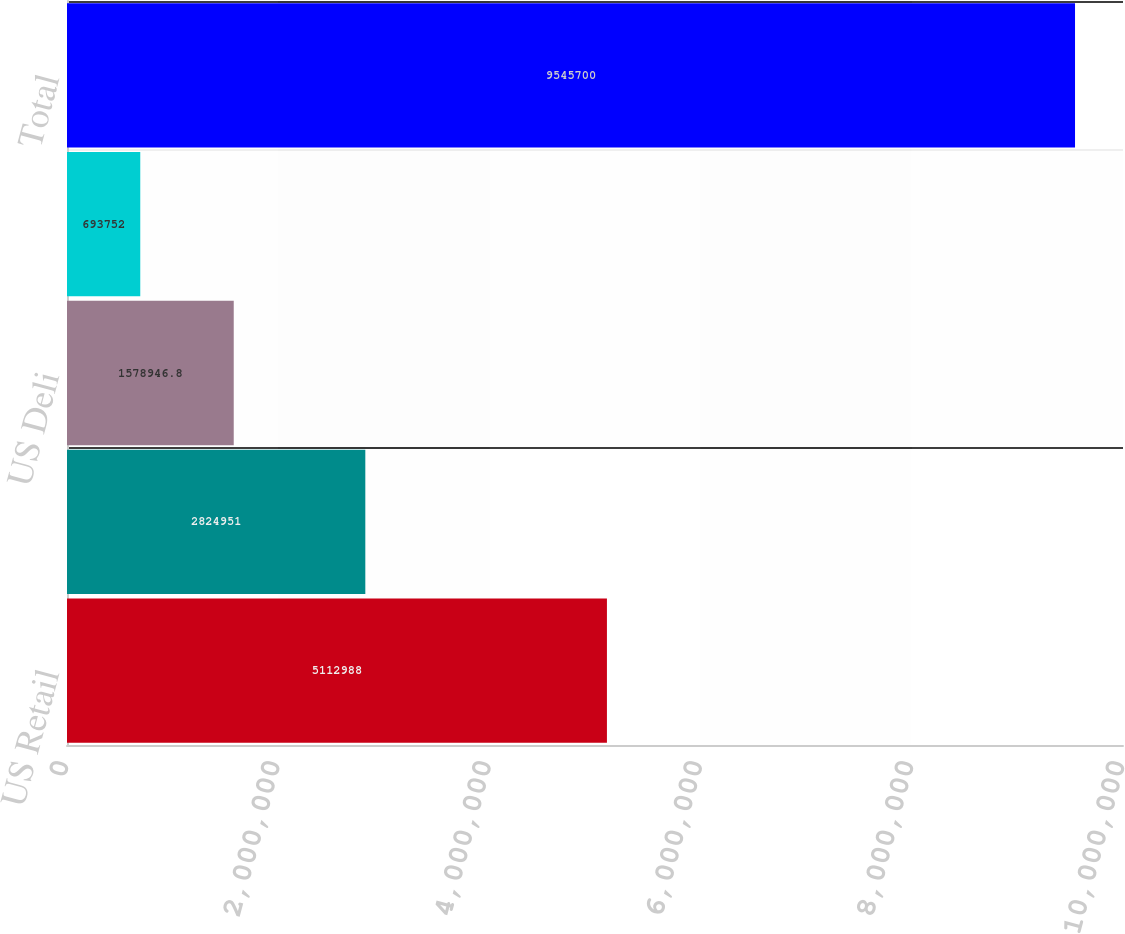Convert chart. <chart><loc_0><loc_0><loc_500><loc_500><bar_chart><fcel>US Retail<fcel>US Foodservice<fcel>US Deli<fcel>International<fcel>Total<nl><fcel>5.11299e+06<fcel>2.82495e+06<fcel>1.57895e+06<fcel>693752<fcel>9.5457e+06<nl></chart> 